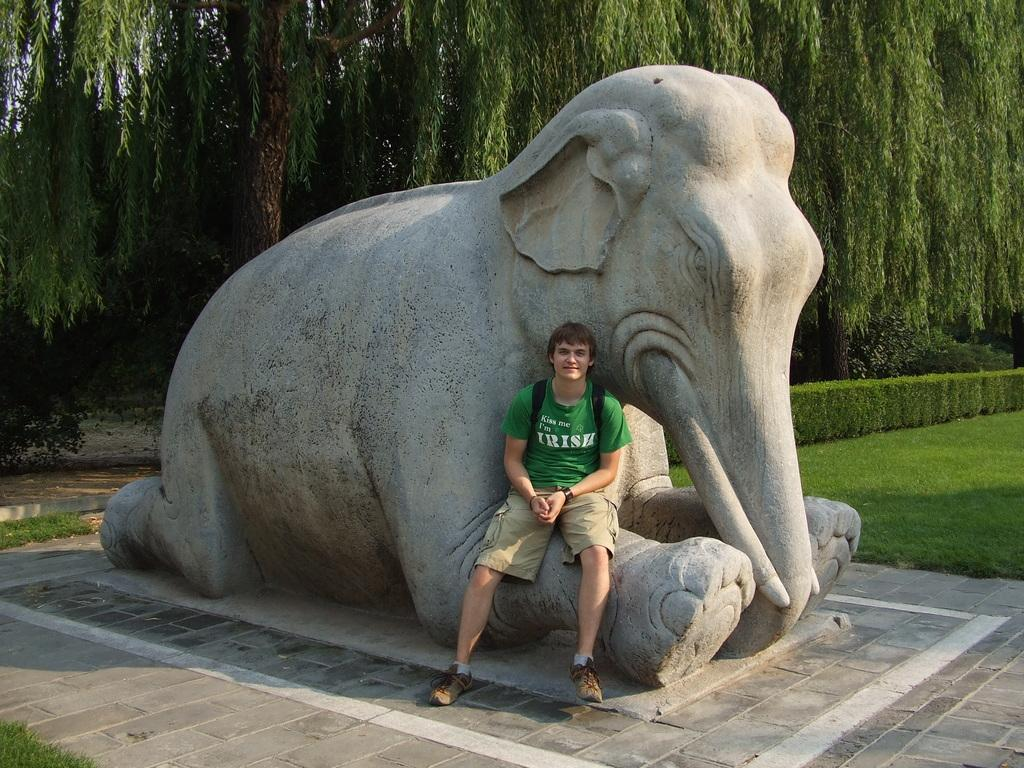Who is present in the image? There is a man in the image. What is the man wearing? The man is wearing a green t-shirt and shorts. What is the man doing in the image? The man is sitting on an elephant statue. What can be seen in the background of the image? There are many trees visible in the image, and there is a garden in front of the trees. What type of behavior does the apple exhibit in the image? There is no apple present in the image, so it is not possible to answer that question. 